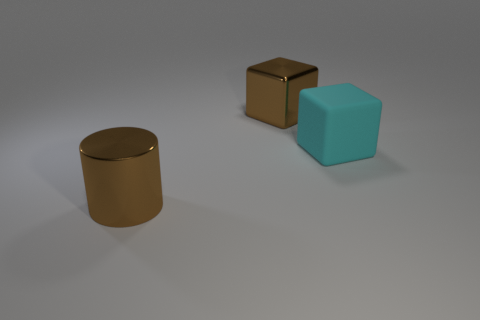Is there anything else that has the same material as the big cyan object?
Offer a terse response. No. Are there more big brown objects in front of the brown metal cylinder than large brown cylinders?
Provide a succinct answer. No. There is a object that is both in front of the large brown metal cube and left of the cyan object; what is it made of?
Give a very brief answer. Metal. Is there any other thing that has the same shape as the cyan rubber object?
Offer a terse response. Yes. How many big objects are both behind the large rubber thing and on the right side of the big metallic block?
Provide a short and direct response. 0. What material is the big brown cube?
Your response must be concise. Metal. Is the number of brown objects that are behind the large matte block the same as the number of cyan matte blocks?
Your answer should be very brief. Yes. How many large brown shiny things have the same shape as the large rubber thing?
Your answer should be compact. 1. How many things are large brown things that are behind the cyan matte object or red shiny balls?
Provide a succinct answer. 1. What shape is the object that is on the left side of the large brown thing behind the big brown object in front of the metal cube?
Your answer should be compact. Cylinder. 